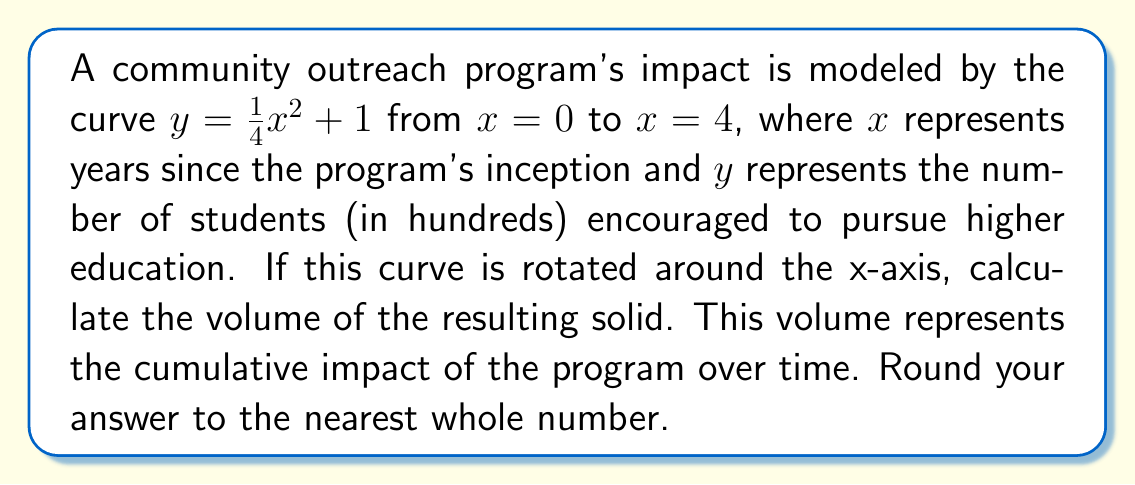Can you answer this question? To solve this problem, we'll use the disk method for calculating the volume of a solid of revolution:

1) The formula for the volume is:
   $$V = \pi \int_a^b [f(x)]^2 dx$$
   where $f(x)$ is our function and $[a,b]$ is our interval.

2) Our function is $f(x) = \frac{1}{4}x^2 + 1$, and we're integrating from $a=0$ to $b=4$.

3) Let's set up the integral:
   $$V = \pi \int_0^4 [\frac{1}{4}x^2 + 1]^2 dx$$

4) Expand the squared term:
   $$V = \pi \int_0^4 [\frac{1}{16}x^4 + \frac{1}{2}x^2 + 1] dx$$

5) Integrate term by term:
   $$V = \pi [\frac{1}{80}x^5 + \frac{1}{6}x^3 + x]_0^4$$

6) Evaluate the integral:
   $$V = \pi [(\frac{1024}{80} + \frac{64}{6} + 4) - (0 + 0 + 0)]$$
   $$V = \pi [\frac{1024}{80} + \frac{64}{6} + 4]$$
   $$V = \pi [12.8 + 10.67 + 4]$$
   $$V = \pi [27.47]$$

7) Calculate and round to the nearest whole number:
   $$V \approx 86.3 \approx 86$$

Therefore, the volume of the solid, representing the cumulative impact of the program, is approximately 86 cubic units.
Answer: 86 cubic units 